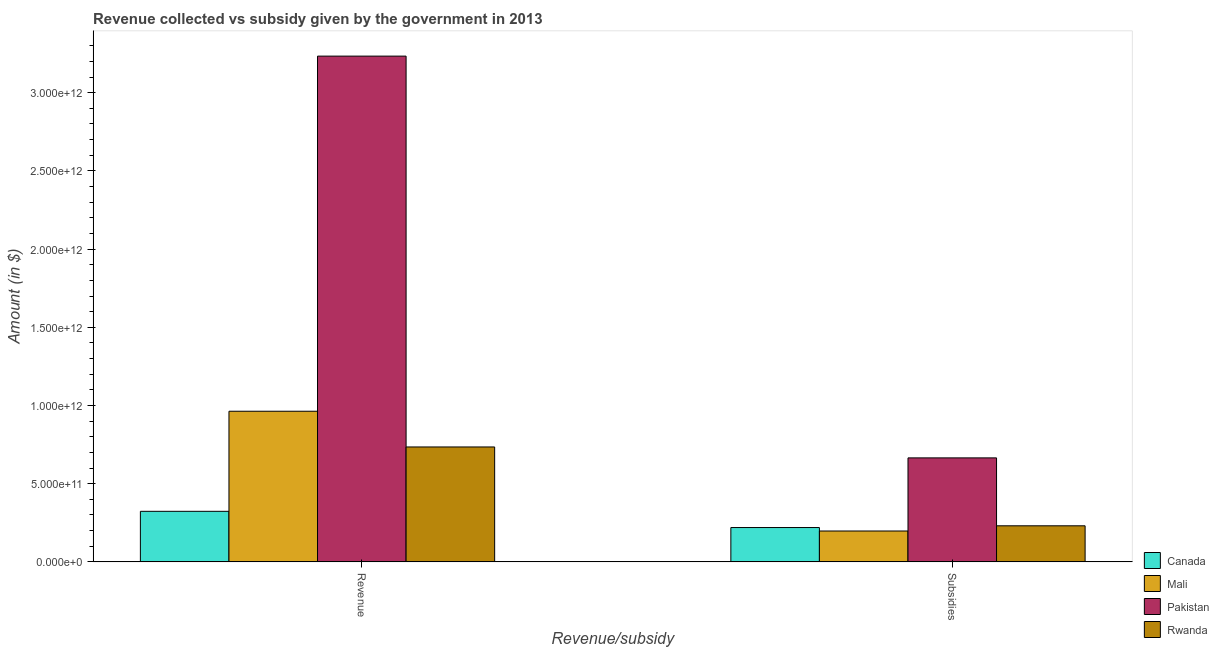How many different coloured bars are there?
Give a very brief answer. 4. How many groups of bars are there?
Keep it short and to the point. 2. Are the number of bars per tick equal to the number of legend labels?
Your answer should be compact. Yes. Are the number of bars on each tick of the X-axis equal?
Provide a succinct answer. Yes. What is the label of the 2nd group of bars from the left?
Provide a succinct answer. Subsidies. What is the amount of revenue collected in Mali?
Give a very brief answer. 9.63e+11. Across all countries, what is the maximum amount of revenue collected?
Keep it short and to the point. 3.23e+12. Across all countries, what is the minimum amount of subsidies given?
Make the answer very short. 1.98e+11. In which country was the amount of subsidies given minimum?
Your response must be concise. Mali. What is the total amount of subsidies given in the graph?
Keep it short and to the point. 1.31e+12. What is the difference between the amount of revenue collected in Canada and that in Pakistan?
Ensure brevity in your answer.  -2.91e+12. What is the difference between the amount of subsidies given in Rwanda and the amount of revenue collected in Canada?
Ensure brevity in your answer.  -9.26e+1. What is the average amount of subsidies given per country?
Offer a very short reply. 3.28e+11. What is the difference between the amount of revenue collected and amount of subsidies given in Mali?
Your response must be concise. 7.66e+11. In how many countries, is the amount of subsidies given greater than 2300000000000 $?
Ensure brevity in your answer.  0. What is the ratio of the amount of subsidies given in Rwanda to that in Mali?
Provide a short and direct response. 1.17. Is the amount of subsidies given in Mali less than that in Pakistan?
Your response must be concise. Yes. What does the 2nd bar from the left in Revenue represents?
Offer a terse response. Mali. How many bars are there?
Provide a short and direct response. 8. Are all the bars in the graph horizontal?
Your answer should be very brief. No. How many countries are there in the graph?
Your answer should be very brief. 4. What is the difference between two consecutive major ticks on the Y-axis?
Give a very brief answer. 5.00e+11. Does the graph contain any zero values?
Make the answer very short. No. Does the graph contain grids?
Keep it short and to the point. No. How many legend labels are there?
Your answer should be very brief. 4. How are the legend labels stacked?
Offer a terse response. Vertical. What is the title of the graph?
Your answer should be very brief. Revenue collected vs subsidy given by the government in 2013. What is the label or title of the X-axis?
Give a very brief answer. Revenue/subsidy. What is the label or title of the Y-axis?
Make the answer very short. Amount (in $). What is the Amount (in $) in Canada in Revenue?
Offer a terse response. 3.23e+11. What is the Amount (in $) of Mali in Revenue?
Make the answer very short. 9.63e+11. What is the Amount (in $) of Pakistan in Revenue?
Offer a very short reply. 3.23e+12. What is the Amount (in $) of Rwanda in Revenue?
Make the answer very short. 7.35e+11. What is the Amount (in $) in Canada in Subsidies?
Keep it short and to the point. 2.20e+11. What is the Amount (in $) of Mali in Subsidies?
Give a very brief answer. 1.98e+11. What is the Amount (in $) of Pakistan in Subsidies?
Offer a very short reply. 6.65e+11. What is the Amount (in $) of Rwanda in Subsidies?
Keep it short and to the point. 2.31e+11. Across all Revenue/subsidy, what is the maximum Amount (in $) of Canada?
Keep it short and to the point. 3.23e+11. Across all Revenue/subsidy, what is the maximum Amount (in $) of Mali?
Offer a very short reply. 9.63e+11. Across all Revenue/subsidy, what is the maximum Amount (in $) in Pakistan?
Provide a short and direct response. 3.23e+12. Across all Revenue/subsidy, what is the maximum Amount (in $) of Rwanda?
Keep it short and to the point. 7.35e+11. Across all Revenue/subsidy, what is the minimum Amount (in $) in Canada?
Keep it short and to the point. 2.20e+11. Across all Revenue/subsidy, what is the minimum Amount (in $) of Mali?
Provide a short and direct response. 1.98e+11. Across all Revenue/subsidy, what is the minimum Amount (in $) of Pakistan?
Offer a terse response. 6.65e+11. Across all Revenue/subsidy, what is the minimum Amount (in $) of Rwanda?
Ensure brevity in your answer.  2.31e+11. What is the total Amount (in $) of Canada in the graph?
Your answer should be compact. 5.43e+11. What is the total Amount (in $) of Mali in the graph?
Give a very brief answer. 1.16e+12. What is the total Amount (in $) of Pakistan in the graph?
Your answer should be compact. 3.90e+12. What is the total Amount (in $) in Rwanda in the graph?
Keep it short and to the point. 9.66e+11. What is the difference between the Amount (in $) of Canada in Revenue and that in Subsidies?
Offer a terse response. 1.04e+11. What is the difference between the Amount (in $) in Mali in Revenue and that in Subsidies?
Provide a short and direct response. 7.66e+11. What is the difference between the Amount (in $) of Pakistan in Revenue and that in Subsidies?
Provide a short and direct response. 2.57e+12. What is the difference between the Amount (in $) of Rwanda in Revenue and that in Subsidies?
Give a very brief answer. 5.04e+11. What is the difference between the Amount (in $) in Canada in Revenue and the Amount (in $) in Mali in Subsidies?
Ensure brevity in your answer.  1.26e+11. What is the difference between the Amount (in $) in Canada in Revenue and the Amount (in $) in Pakistan in Subsidies?
Your answer should be compact. -3.42e+11. What is the difference between the Amount (in $) in Canada in Revenue and the Amount (in $) in Rwanda in Subsidies?
Make the answer very short. 9.26e+1. What is the difference between the Amount (in $) in Mali in Revenue and the Amount (in $) in Pakistan in Subsidies?
Give a very brief answer. 2.98e+11. What is the difference between the Amount (in $) of Mali in Revenue and the Amount (in $) of Rwanda in Subsidies?
Your answer should be compact. 7.32e+11. What is the difference between the Amount (in $) in Pakistan in Revenue and the Amount (in $) in Rwanda in Subsidies?
Your response must be concise. 3.00e+12. What is the average Amount (in $) of Canada per Revenue/subsidy?
Your answer should be compact. 2.72e+11. What is the average Amount (in $) of Mali per Revenue/subsidy?
Offer a terse response. 5.80e+11. What is the average Amount (in $) in Pakistan per Revenue/subsidy?
Ensure brevity in your answer.  1.95e+12. What is the average Amount (in $) of Rwanda per Revenue/subsidy?
Your answer should be compact. 4.83e+11. What is the difference between the Amount (in $) in Canada and Amount (in $) in Mali in Revenue?
Your response must be concise. -6.40e+11. What is the difference between the Amount (in $) of Canada and Amount (in $) of Pakistan in Revenue?
Offer a terse response. -2.91e+12. What is the difference between the Amount (in $) of Canada and Amount (in $) of Rwanda in Revenue?
Your response must be concise. -4.12e+11. What is the difference between the Amount (in $) of Mali and Amount (in $) of Pakistan in Revenue?
Give a very brief answer. -2.27e+12. What is the difference between the Amount (in $) in Mali and Amount (in $) in Rwanda in Revenue?
Your response must be concise. 2.28e+11. What is the difference between the Amount (in $) in Pakistan and Amount (in $) in Rwanda in Revenue?
Offer a terse response. 2.50e+12. What is the difference between the Amount (in $) of Canada and Amount (in $) of Mali in Subsidies?
Your answer should be very brief. 2.21e+1. What is the difference between the Amount (in $) in Canada and Amount (in $) in Pakistan in Subsidies?
Your answer should be very brief. -4.45e+11. What is the difference between the Amount (in $) in Canada and Amount (in $) in Rwanda in Subsidies?
Offer a terse response. -1.11e+1. What is the difference between the Amount (in $) of Mali and Amount (in $) of Pakistan in Subsidies?
Your response must be concise. -4.67e+11. What is the difference between the Amount (in $) in Mali and Amount (in $) in Rwanda in Subsidies?
Provide a succinct answer. -3.32e+1. What is the difference between the Amount (in $) in Pakistan and Amount (in $) in Rwanda in Subsidies?
Offer a terse response. 4.34e+11. What is the ratio of the Amount (in $) in Canada in Revenue to that in Subsidies?
Provide a succinct answer. 1.47. What is the ratio of the Amount (in $) of Mali in Revenue to that in Subsidies?
Make the answer very short. 4.88. What is the ratio of the Amount (in $) of Pakistan in Revenue to that in Subsidies?
Offer a terse response. 4.86. What is the ratio of the Amount (in $) of Rwanda in Revenue to that in Subsidies?
Your response must be concise. 3.18. What is the difference between the highest and the second highest Amount (in $) of Canada?
Offer a very short reply. 1.04e+11. What is the difference between the highest and the second highest Amount (in $) in Mali?
Keep it short and to the point. 7.66e+11. What is the difference between the highest and the second highest Amount (in $) of Pakistan?
Ensure brevity in your answer.  2.57e+12. What is the difference between the highest and the second highest Amount (in $) of Rwanda?
Provide a short and direct response. 5.04e+11. What is the difference between the highest and the lowest Amount (in $) in Canada?
Your response must be concise. 1.04e+11. What is the difference between the highest and the lowest Amount (in $) in Mali?
Provide a succinct answer. 7.66e+11. What is the difference between the highest and the lowest Amount (in $) in Pakistan?
Offer a very short reply. 2.57e+12. What is the difference between the highest and the lowest Amount (in $) in Rwanda?
Give a very brief answer. 5.04e+11. 